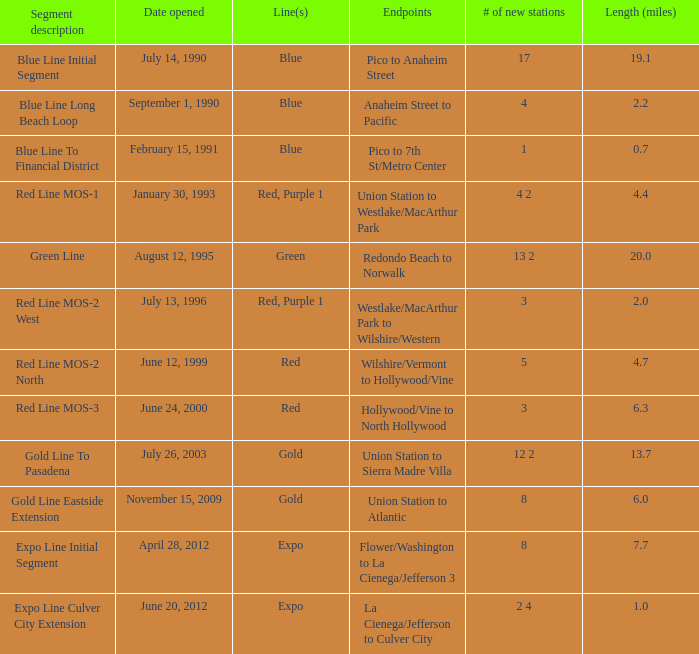What is the length in miles from westlake/macarthur park to wilshire/western endpoints? 2.0. 